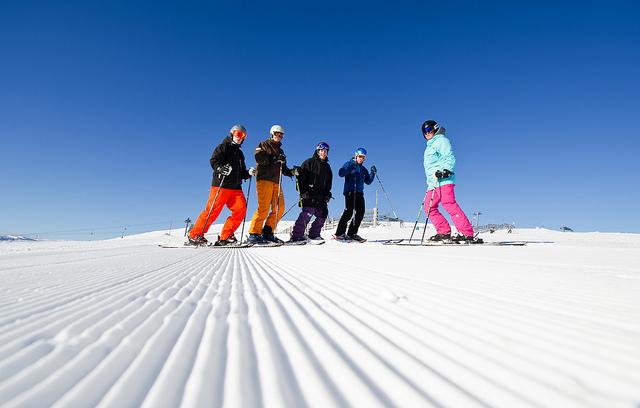Has the slope been recently groomed?
Answer briefly. Yes. How many people are wearing black pants?
Keep it brief. 2. Are the skiers cold?
Concise answer only. Yes. 